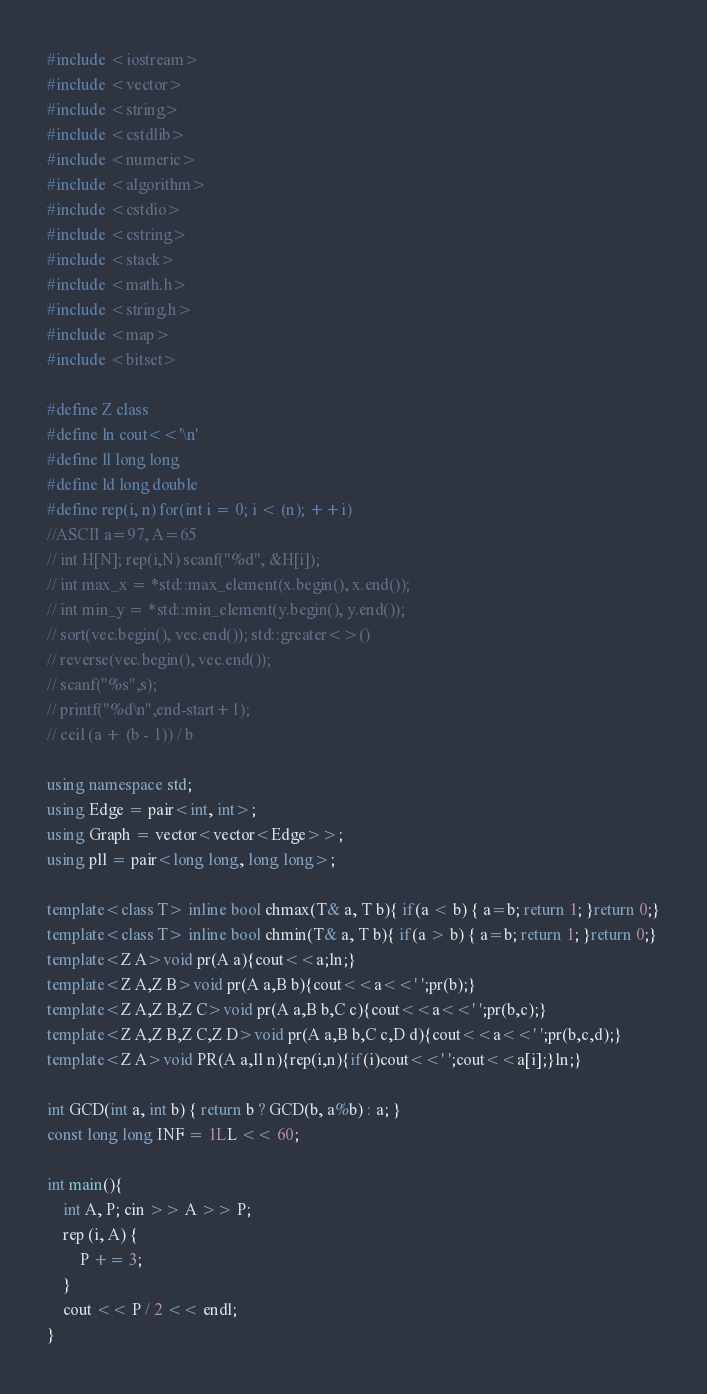Convert code to text. <code><loc_0><loc_0><loc_500><loc_500><_C++_>#include <iostream>
#include <vector>
#include <string>
#include <cstdlib>
#include <numeric>
#include <algorithm>
#include <cstdio>
#include <cstring>
#include <stack>
#include <math.h>
#include <string.h>
#include <map>
#include <bitset>

#define Z class
#define ln cout<<'\n'
#define ll long long
#define ld long double
#define rep(i, n) for(int i = 0; i < (n); ++i)
//ASCII a=97, A=65
// int H[N]; rep(i,N) scanf("%d", &H[i]);
// int max_x = *std::max_element(x.begin(), x.end());
// int min_y = *std::min_element(y.begin(), y.end());
// sort(vec.begin(), vec.end()); std::greater<>()
// reverse(vec.begin(), vec.end());
// scanf("%s",s);
// printf("%d\n",end-start+1);
// ceil (a + (b - 1)) / b

using namespace std;
using Edge = pair<int, int>;
using Graph = vector<vector<Edge>>;
using pll = pair<long long, long long>;

template<class T> inline bool chmax(T& a, T b){ if(a < b) { a=b; return 1; }return 0;}
template<class T> inline bool chmin(T& a, T b){ if(a > b) { a=b; return 1; }return 0;}
template<Z A>void pr(A a){cout<<a;ln;}
template<Z A,Z B>void pr(A a,B b){cout<<a<<' ';pr(b);}
template<Z A,Z B,Z C>void pr(A a,B b,C c){cout<<a<<' ';pr(b,c);}
template<Z A,Z B,Z C,Z D>void pr(A a,B b,C c,D d){cout<<a<<' ';pr(b,c,d);}
template<Z A>void PR(A a,ll n){rep(i,n){if(i)cout<<' ';cout<<a[i];}ln;}

int GCD(int a, int b) { return b ? GCD(b, a%b) : a; }
const long long INF = 1LL << 60;

int main(){
    int A, P; cin >> A >> P;
    rep (i, A) {
        P += 3;
    }
    cout << P / 2 << endl;
}
</code> 